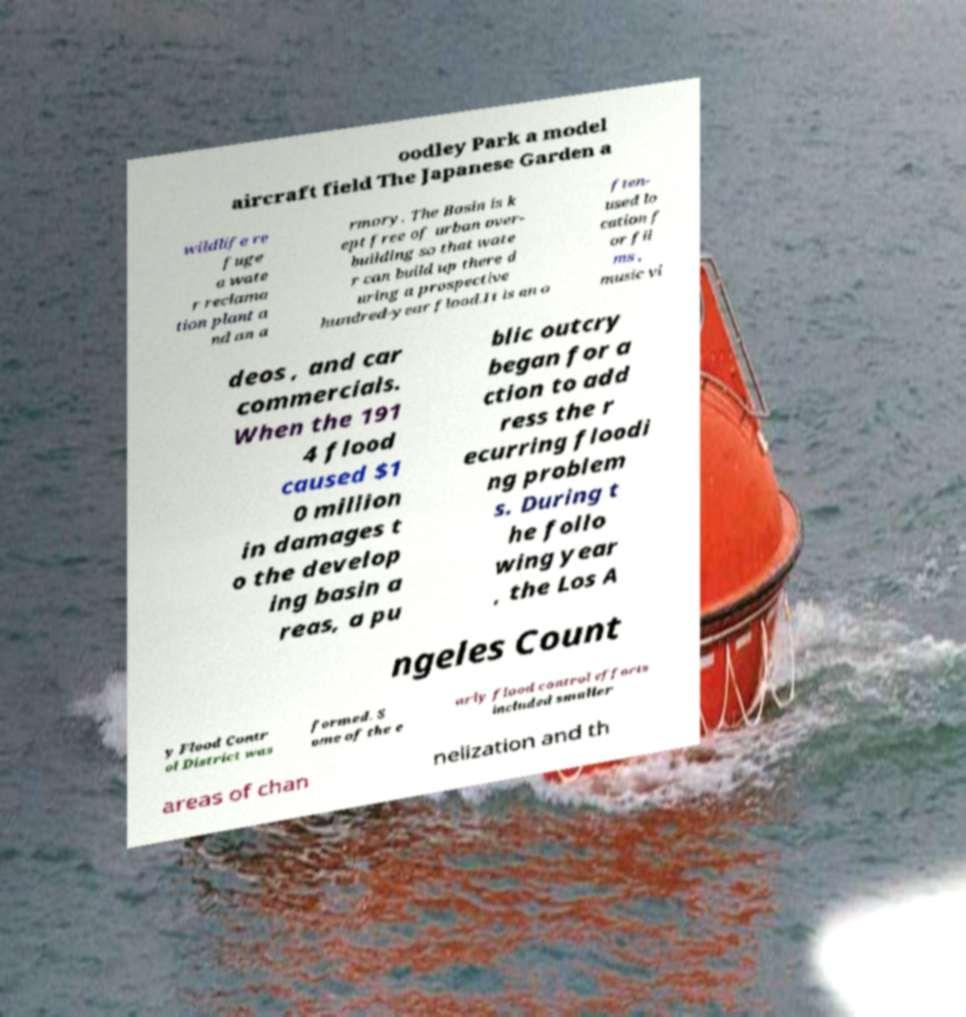I need the written content from this picture converted into text. Can you do that? oodley Park a model aircraft field The Japanese Garden a wildlife re fuge a wate r reclama tion plant a nd an a rmory. The Basin is k ept free of urban over- building so that wate r can build up there d uring a prospective hundred-year flood.It is an o ften- used lo cation f or fil ms , music vi deos , and car commercials. When the 191 4 flood caused $1 0 million in damages t o the develop ing basin a reas, a pu blic outcry began for a ction to add ress the r ecurring floodi ng problem s. During t he follo wing year , the Los A ngeles Count y Flood Contr ol District was formed. S ome of the e arly flood control efforts included smaller areas of chan nelization and th 